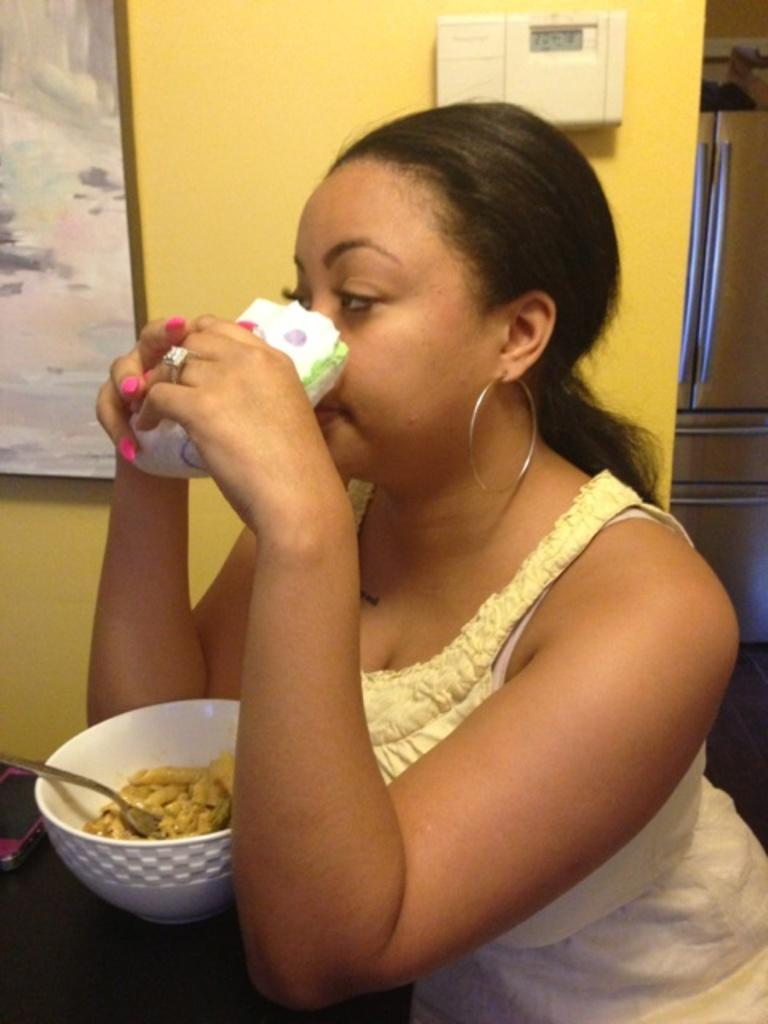What is the woman doing in the image? The woman is sitting at the table in the image. What object is on the table besides the woman? There is a mobile phone, a bowl, a spoon, and food on the table. What might the woman be using to communicate in the image? The mobile phone on the table might be used for communication. What is the woman likely eating in the image? The food on the table suggests that the woman is likely eating something. What can be seen in the background of the image? There is a wall and a photo frame in the background of the image. What degree does the woman need to complete her studies in the image? There is no information about the woman's studies or degree in the image. 